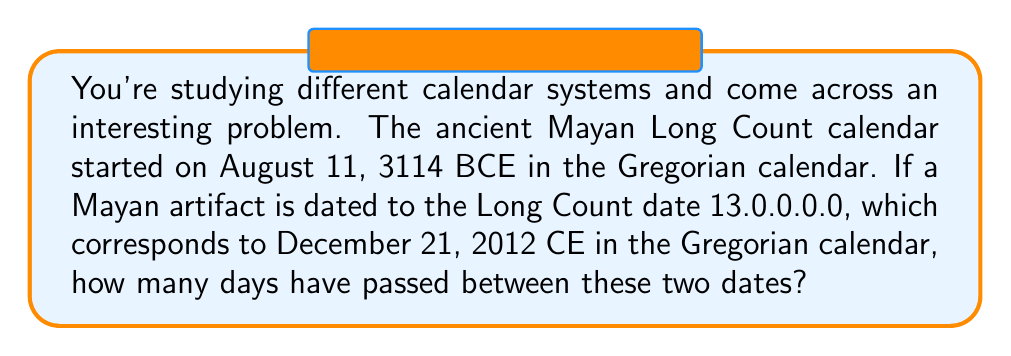Provide a solution to this math problem. To solve this problem, we need to follow these steps:

1) First, let's convert both dates to a common format. We'll use the Gregorian calendar as our reference.

   Start date: August 11, 3114 BCE
   End date: December 21, 2012 CE

2) Now, we need to calculate the number of days between these two dates. We can use the following formula:

   $$ \text{Days} = 365 \cdot (\text{Year}_2 - \text{Year}_1) + \text{LeapDays} + (\text{DayOfYear}_2 - \text{DayOfYear}_1) $$

3) Let's break this down:
   
   $\text{Year}_2 - \text{Year}_1 = 2012 - (-3114) = 5126$ (remember BCE years are negative)

4) To calculate leap days, we need to consider that:
   - Every 4th year is a leap year
   - Except every 100th year is not a leap year
   - Unless it's also divisible by 400, then it is a leap year

   $\text{LeapDays} = \lfloor \frac{5126}{4} \rfloor - \lfloor \frac{5126}{100} \rfloor + \lfloor \frac{5126}{400} \rfloor = 1281 - 51 + 12 = 1242$

5) Now for the day of the year:
   August 11 is the 223rd day of the year
   December 21 is the 355th day of the year

   $355 - 223 = 132$

6) Putting it all together:

   $$ \text{Days} = 365 \cdot 5126 + 1242 + 132 = 1,872,000 $$

Therefore, 1,872,000 days have passed between these two dates in the Mayan Long Count calendar.
Answer: 1,872,000 days 